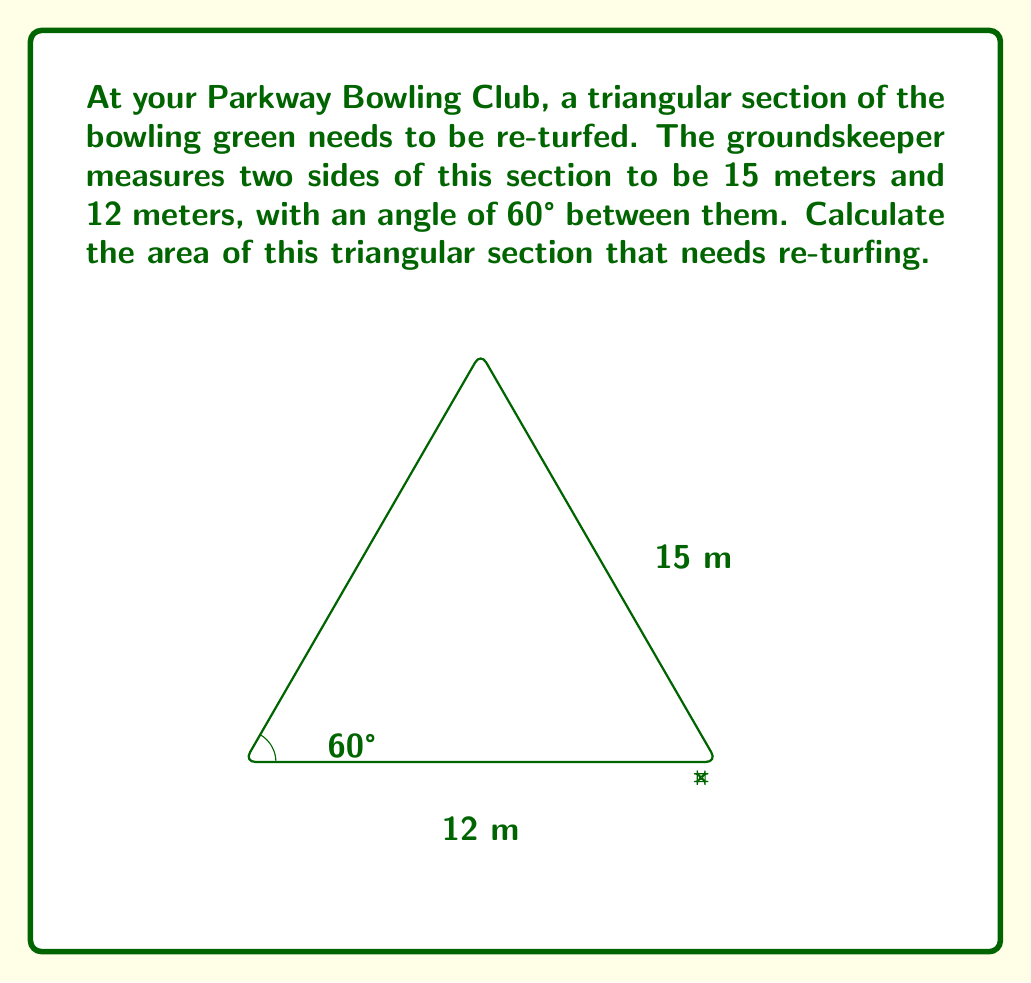Can you solve this math problem? To solve this problem, we can use the formula for the area of a triangle given two sides and the included angle:

$$ A = \frac{1}{2} ab \sin C $$

Where:
$A$ is the area of the triangle
$a$ and $b$ are the lengths of the two known sides
$C$ is the angle between these sides

Given:
$a = 15$ meters
$b = 12$ meters
$C = 60°$

Step 1: Convert 60° to radians (optional, but often preferred for trigonometric calculations)
$60° = \frac{\pi}{3}$ radians

Step 2: Substitute the values into the formula
$$ A = \frac{1}{2} \cdot 15 \cdot 12 \cdot \sin(\frac{\pi}{3}) $$

Step 3: Calculate $\sin(\frac{\pi}{3})$
$\sin(\frac{\pi}{3}) = \frac{\sqrt{3}}{2}$

Step 4: Substitute this value and calculate
$$ A = \frac{1}{2} \cdot 15 \cdot 12 \cdot \frac{\sqrt{3}}{2} $$
$$ A = 45 \cdot \frac{\sqrt{3}}{2} $$
$$ A = \frac{45\sqrt{3}}{2} $$

Step 5: Simplify if needed (or leave in surd form)
$$ A \approx 38.97 \text{ square meters} $$
Answer: The area of the triangular section is $\frac{45\sqrt{3}}{2}$ square meters, or approximately 38.97 square meters. 